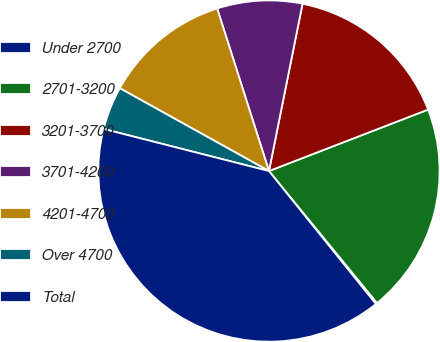<chart> <loc_0><loc_0><loc_500><loc_500><pie_chart><fcel>Under 2700<fcel>2701-3200<fcel>3201-3700<fcel>3701-4200<fcel>4201-4700<fcel>Over 4700<fcel>Total<nl><fcel>0.14%<fcel>19.94%<fcel>15.98%<fcel>8.06%<fcel>12.02%<fcel>4.1%<fcel>39.74%<nl></chart> 